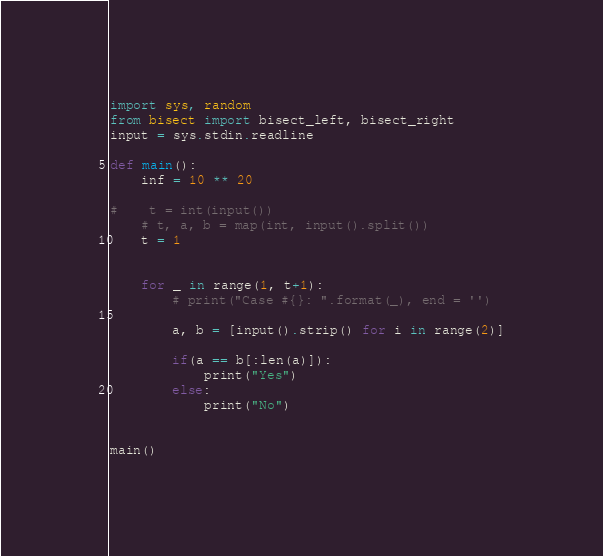<code> <loc_0><loc_0><loc_500><loc_500><_Python_>import sys, random
from bisect import bisect_left, bisect_right
input = sys.stdin.readline

def main():
    inf = 10 ** 20

#    t = int(input())
    # t, a, b = map(int, input().split())
    t = 1
    
    
    for _ in range(1, t+1):
        # print("Case #{}: ".format(_), end = '')
        
        a, b = [input().strip() for i in range(2)]
        
        if(a == b[:len(a)]):
            print("Yes")
        else:
            print("No")
        
        
main()</code> 